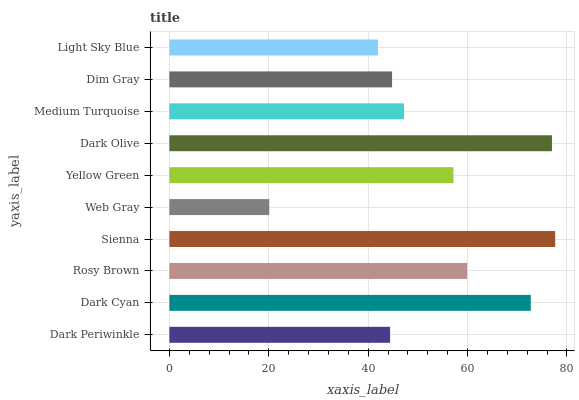Is Web Gray the minimum?
Answer yes or no. Yes. Is Sienna the maximum?
Answer yes or no. Yes. Is Dark Cyan the minimum?
Answer yes or no. No. Is Dark Cyan the maximum?
Answer yes or no. No. Is Dark Cyan greater than Dark Periwinkle?
Answer yes or no. Yes. Is Dark Periwinkle less than Dark Cyan?
Answer yes or no. Yes. Is Dark Periwinkle greater than Dark Cyan?
Answer yes or no. No. Is Dark Cyan less than Dark Periwinkle?
Answer yes or no. No. Is Yellow Green the high median?
Answer yes or no. Yes. Is Medium Turquoise the low median?
Answer yes or no. Yes. Is Rosy Brown the high median?
Answer yes or no. No. Is Light Sky Blue the low median?
Answer yes or no. No. 